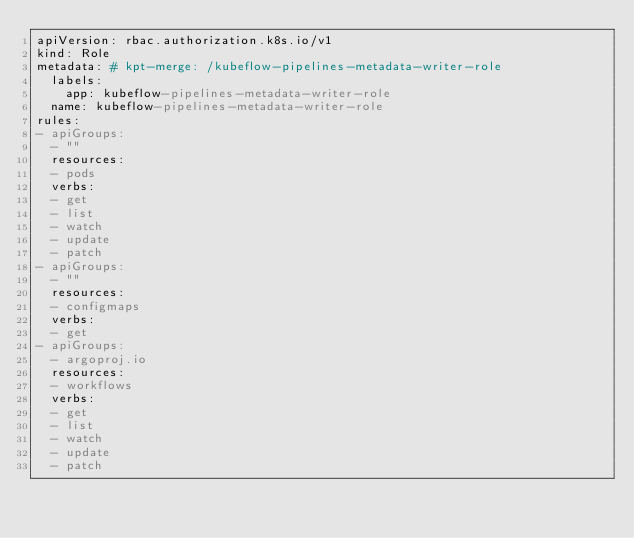Convert code to text. <code><loc_0><loc_0><loc_500><loc_500><_YAML_>apiVersion: rbac.authorization.k8s.io/v1
kind: Role
metadata: # kpt-merge: /kubeflow-pipelines-metadata-writer-role
  labels:
    app: kubeflow-pipelines-metadata-writer-role
  name: kubeflow-pipelines-metadata-writer-role
rules:
- apiGroups:
  - ""
  resources:
  - pods
  verbs:
  - get
  - list
  - watch
  - update
  - patch
- apiGroups:
  - ""
  resources:
  - configmaps
  verbs:
  - get
- apiGroups:
  - argoproj.io
  resources:
  - workflows
  verbs:
  - get
  - list
  - watch
  - update
  - patch
</code> 